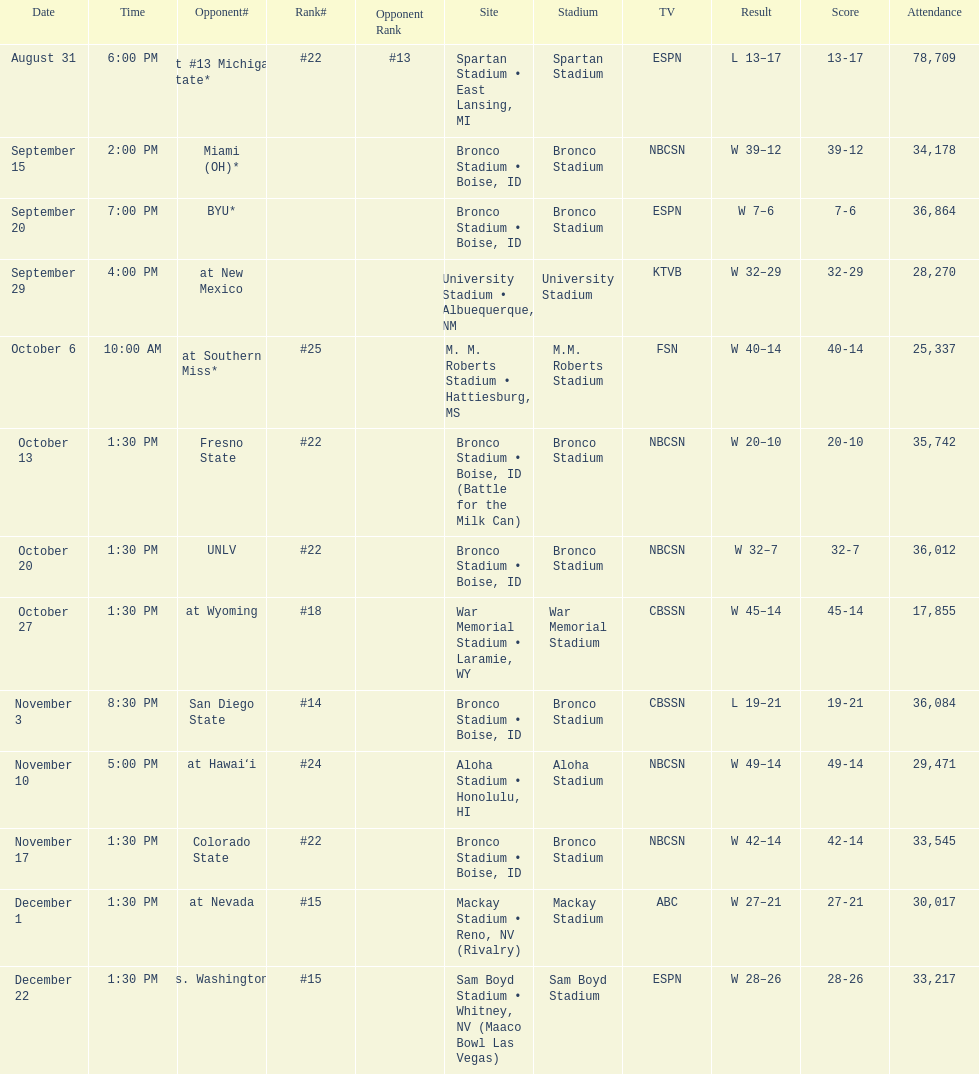What rank was boise state after november 10th? #22. 